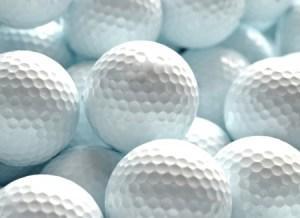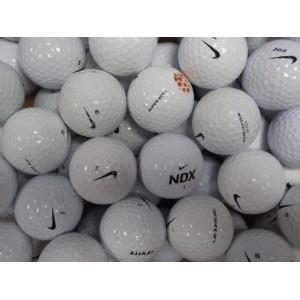The first image is the image on the left, the second image is the image on the right. Evaluate the accuracy of this statement regarding the images: "In at least in image there are at least thirty dirty and muddy golf balls.". Is it true? Answer yes or no. No. The first image is the image on the left, the second image is the image on the right. For the images shown, is this caption "One of the images contains nothing but golf balls, the other shows a brown that contains them." true? Answer yes or no. No. 